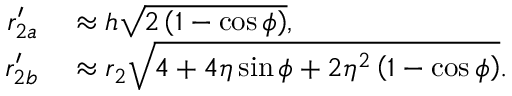Convert formula to latex. <formula><loc_0><loc_0><loc_500><loc_500>\begin{array} { r l } { r _ { 2 a } ^ { \prime } } & \approx h \sqrt { 2 \left ( 1 - \cos { \phi } \right ) } , } \\ { r _ { 2 b } ^ { \prime } } & \approx r _ { 2 } \sqrt { 4 + 4 \eta \sin { \phi } + 2 \eta ^ { 2 } \left ( 1 - \cos { \phi } \right ) } . } \end{array}</formula> 